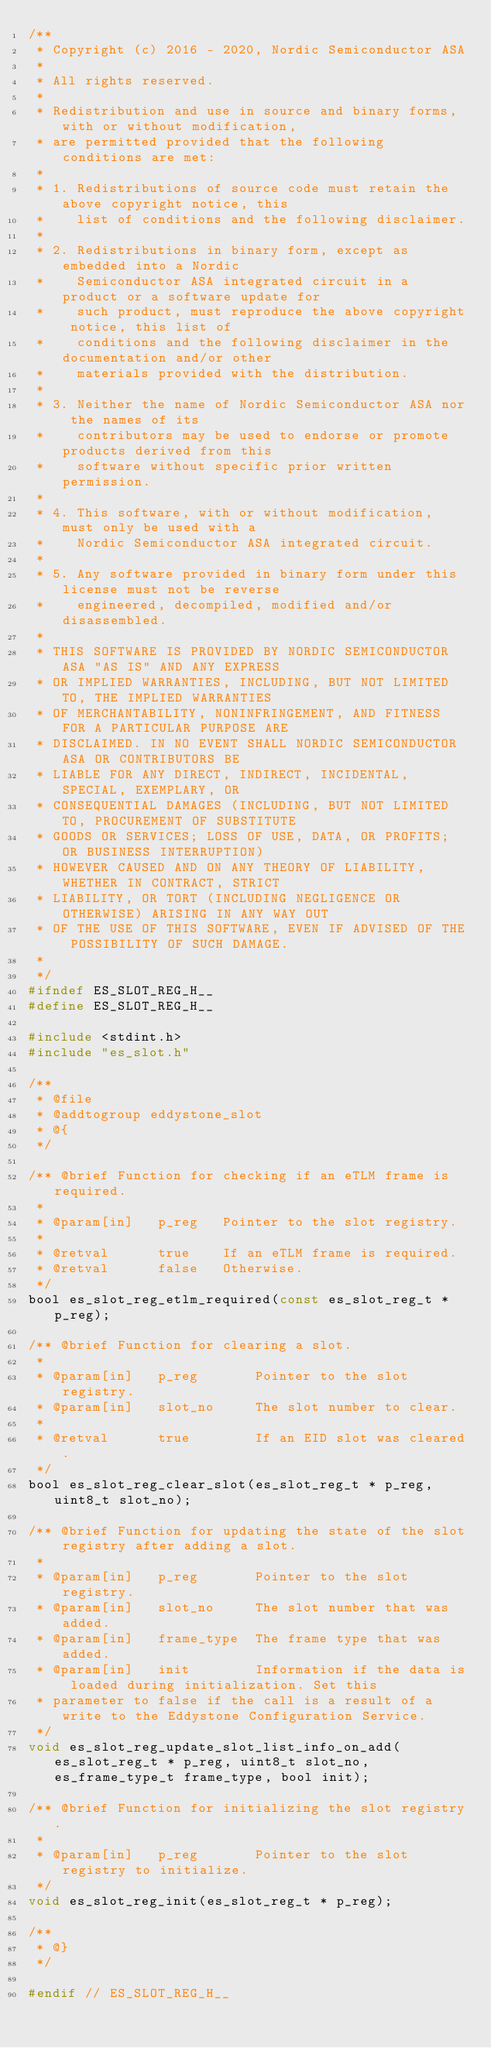<code> <loc_0><loc_0><loc_500><loc_500><_C_>/**
 * Copyright (c) 2016 - 2020, Nordic Semiconductor ASA
 *
 * All rights reserved.
 *
 * Redistribution and use in source and binary forms, with or without modification,
 * are permitted provided that the following conditions are met:
 *
 * 1. Redistributions of source code must retain the above copyright notice, this
 *    list of conditions and the following disclaimer.
 *
 * 2. Redistributions in binary form, except as embedded into a Nordic
 *    Semiconductor ASA integrated circuit in a product or a software update for
 *    such product, must reproduce the above copyright notice, this list of
 *    conditions and the following disclaimer in the documentation and/or other
 *    materials provided with the distribution.
 *
 * 3. Neither the name of Nordic Semiconductor ASA nor the names of its
 *    contributors may be used to endorse or promote products derived from this
 *    software without specific prior written permission.
 *
 * 4. This software, with or without modification, must only be used with a
 *    Nordic Semiconductor ASA integrated circuit.
 *
 * 5. Any software provided in binary form under this license must not be reverse
 *    engineered, decompiled, modified and/or disassembled.
 *
 * THIS SOFTWARE IS PROVIDED BY NORDIC SEMICONDUCTOR ASA "AS IS" AND ANY EXPRESS
 * OR IMPLIED WARRANTIES, INCLUDING, BUT NOT LIMITED TO, THE IMPLIED WARRANTIES
 * OF MERCHANTABILITY, NONINFRINGEMENT, AND FITNESS FOR A PARTICULAR PURPOSE ARE
 * DISCLAIMED. IN NO EVENT SHALL NORDIC SEMICONDUCTOR ASA OR CONTRIBUTORS BE
 * LIABLE FOR ANY DIRECT, INDIRECT, INCIDENTAL, SPECIAL, EXEMPLARY, OR
 * CONSEQUENTIAL DAMAGES (INCLUDING, BUT NOT LIMITED TO, PROCUREMENT OF SUBSTITUTE
 * GOODS OR SERVICES; LOSS OF USE, DATA, OR PROFITS; OR BUSINESS INTERRUPTION)
 * HOWEVER CAUSED AND ON ANY THEORY OF LIABILITY, WHETHER IN CONTRACT, STRICT
 * LIABILITY, OR TORT (INCLUDING NEGLIGENCE OR OTHERWISE) ARISING IN ANY WAY OUT
 * OF THE USE OF THIS SOFTWARE, EVEN IF ADVISED OF THE POSSIBILITY OF SUCH DAMAGE.
 *
 */
#ifndef ES_SLOT_REG_H__
#define ES_SLOT_REG_H__

#include <stdint.h>
#include "es_slot.h"

/**
 * @file
 * @addtogroup eddystone_slot
 * @{
 */

/** @brief Function for checking if an eTLM frame is required.
 *
 * @param[in]   p_reg   Pointer to the slot registry.
 *
 * @retval      true    If an eTLM frame is required.
 * @retval      false   Otherwise.
 */
bool es_slot_reg_etlm_required(const es_slot_reg_t * p_reg);

/** @brief Function for clearing a slot.
 *
 * @param[in]   p_reg       Pointer to the slot registry.
 * @param[in]   slot_no     The slot number to clear.
 *
 * @retval      true        If an EID slot was cleared.
 */
bool es_slot_reg_clear_slot(es_slot_reg_t * p_reg, uint8_t slot_no);

/** @brief Function for updating the state of the slot registry after adding a slot.
 *
 * @param[in]   p_reg       Pointer to the slot registry.
 * @param[in]   slot_no     The slot number that was added.
 * @param[in]   frame_type  The frame type that was added.
 * @param[in]   init        Information if the data is loaded during initialization. Set this
 * parameter to false if the call is a result of a write to the Eddystone Configuration Service.
 */
void es_slot_reg_update_slot_list_info_on_add(es_slot_reg_t * p_reg, uint8_t slot_no, es_frame_type_t frame_type, bool init);

/** @brief Function for initializing the slot registry.
 *
 * @param[in]   p_reg       Pointer to the slot registry to initialize.
 */
void es_slot_reg_init(es_slot_reg_t * p_reg);

/**
 * @}
 */

#endif // ES_SLOT_REG_H__
</code> 